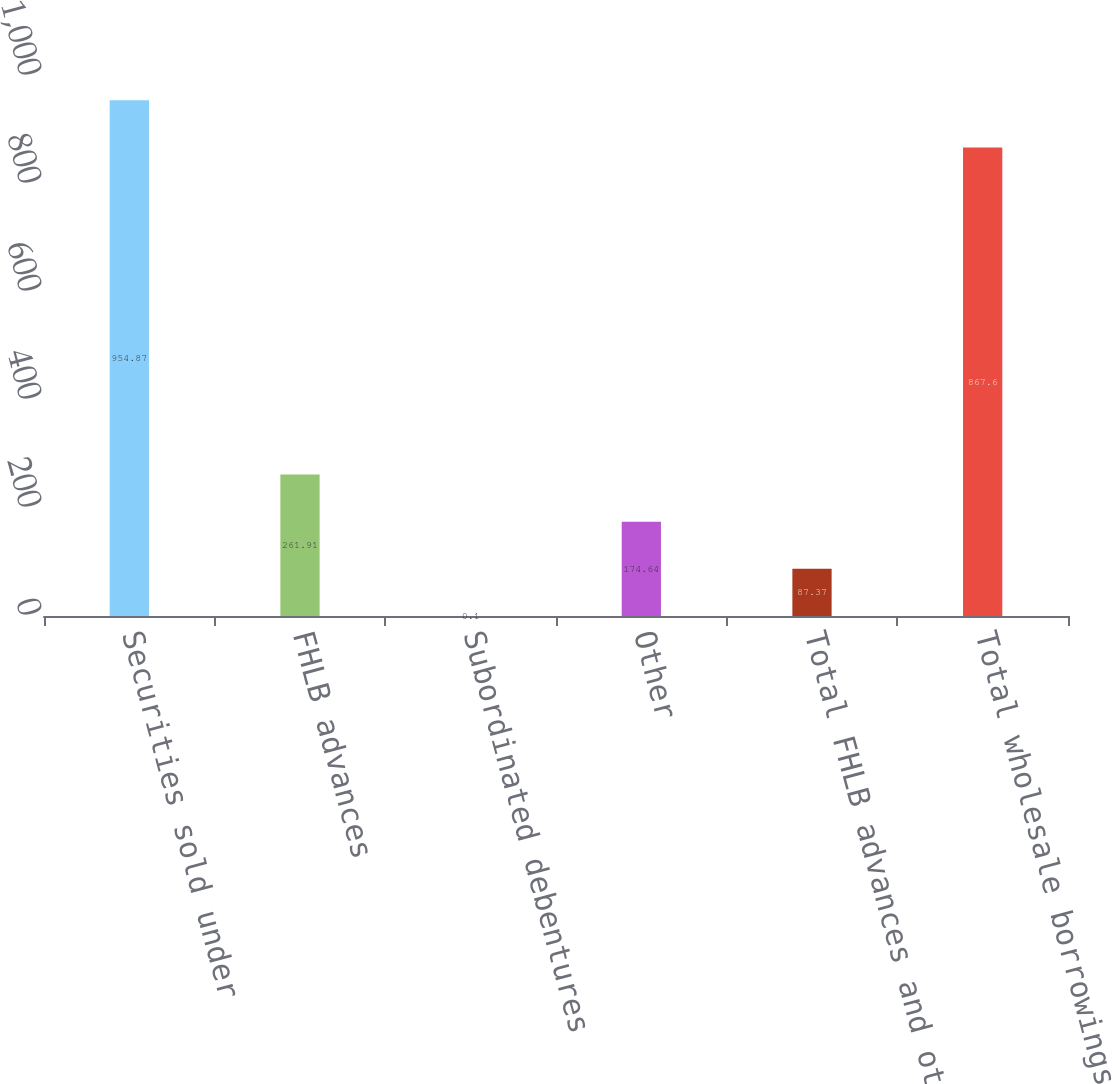Convert chart. <chart><loc_0><loc_0><loc_500><loc_500><bar_chart><fcel>Securities sold under<fcel>FHLB advances<fcel>Subordinated debentures<fcel>Other<fcel>Total FHLB advances and other<fcel>Total wholesale borrowings<nl><fcel>954.87<fcel>261.91<fcel>0.1<fcel>174.64<fcel>87.37<fcel>867.6<nl></chart> 